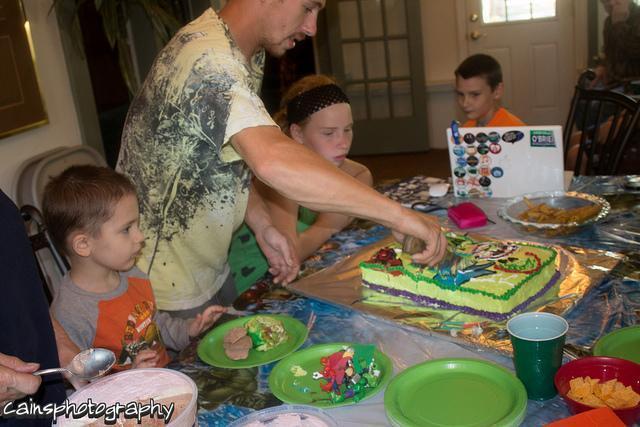How many chairs are there?
Give a very brief answer. 2. How many people are in the photo?
Give a very brief answer. 6. How many bowls are there?
Give a very brief answer. 2. How many dining tables are there?
Give a very brief answer. 1. 